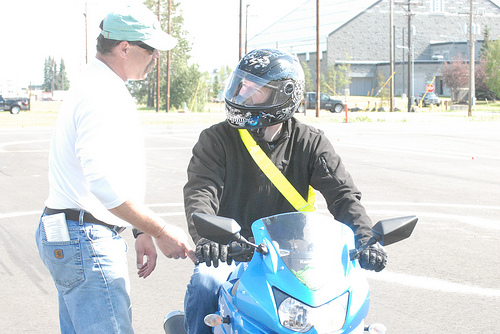<image>
Is there a pole behind the car? No. The pole is not behind the car. From this viewpoint, the pole appears to be positioned elsewhere in the scene. 